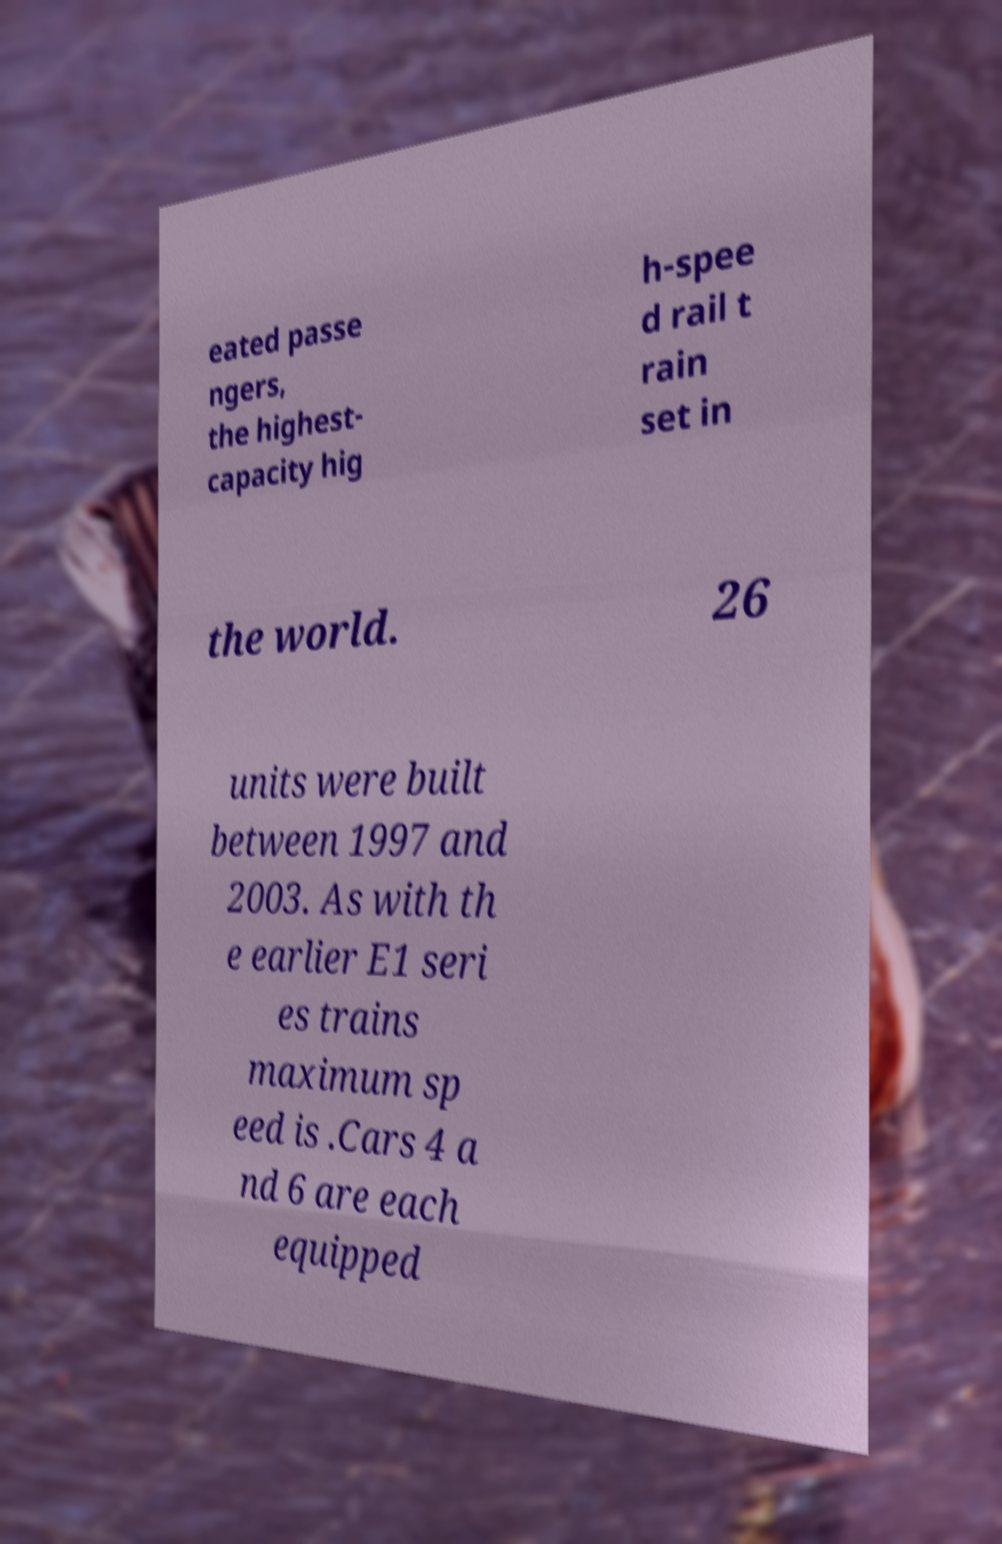Please identify and transcribe the text found in this image. eated passe ngers, the highest- capacity hig h-spee d rail t rain set in the world. 26 units were built between 1997 and 2003. As with th e earlier E1 seri es trains maximum sp eed is .Cars 4 a nd 6 are each equipped 